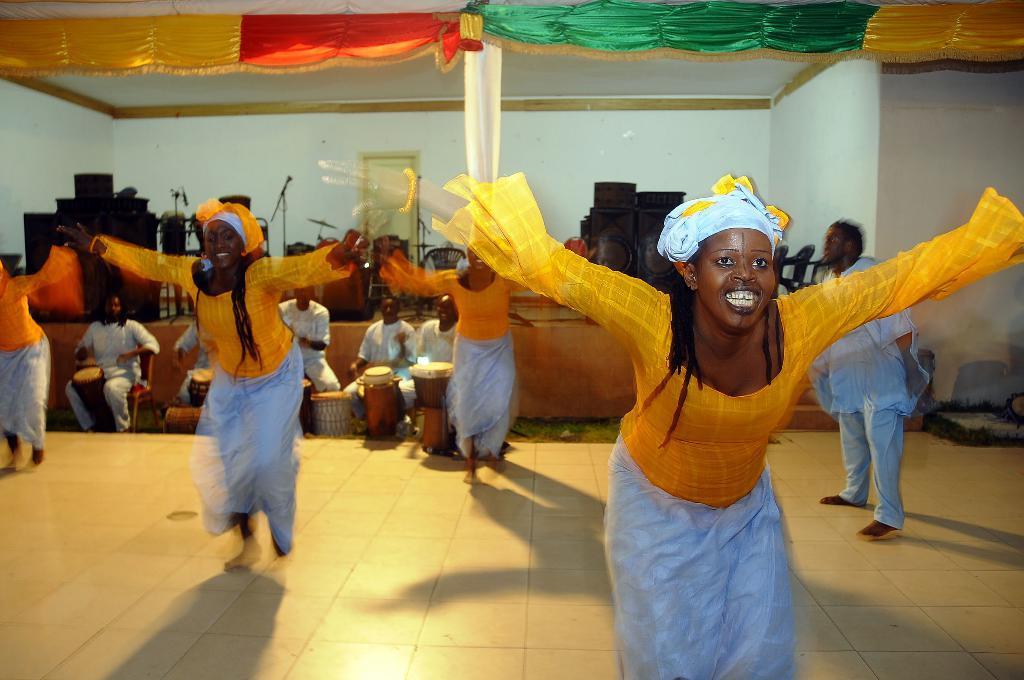In one or two sentences, can you explain what this image depicts? This image is taken indoors. At the bottom of the image there is a floor. In the background there is a wall. At the top of the image there is a roof and there are a few colorful clothes. In the background there are a few musical instruments, mics and a few chairs on the dais and a few men are sitting on the chairs and playing music with musical instruments. In the middle of the image a few women are performing and a man is standing on the floor. 